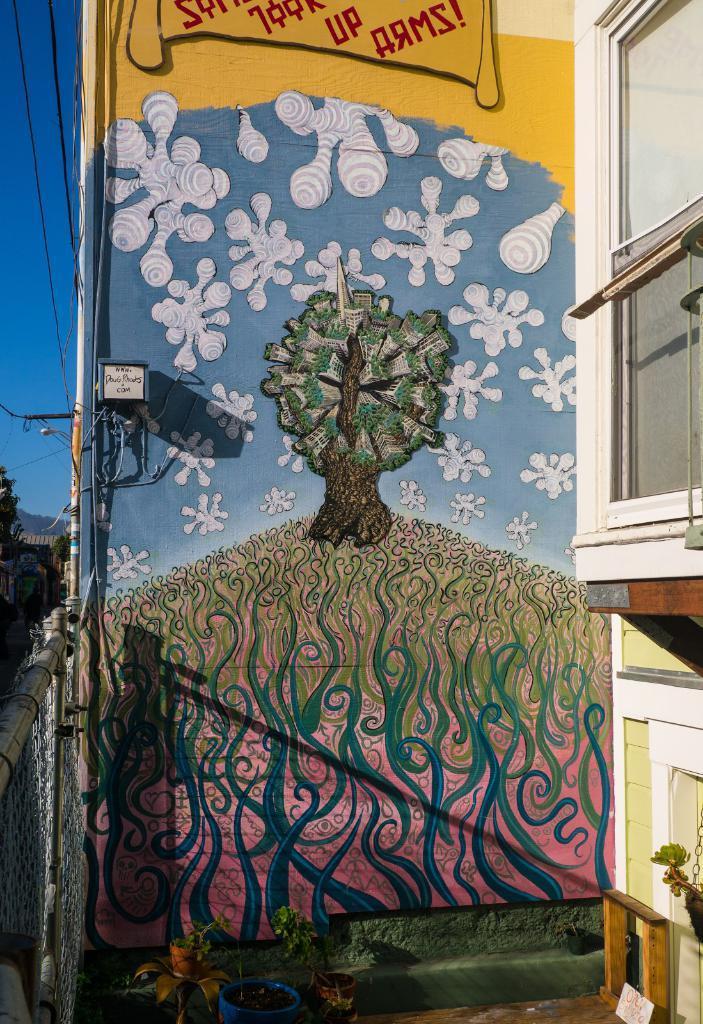In one or two sentences, can you explain what this image depicts? In this picture I can see there is a painting of a tree and there is a building here on the left side and a fence on the right side. 